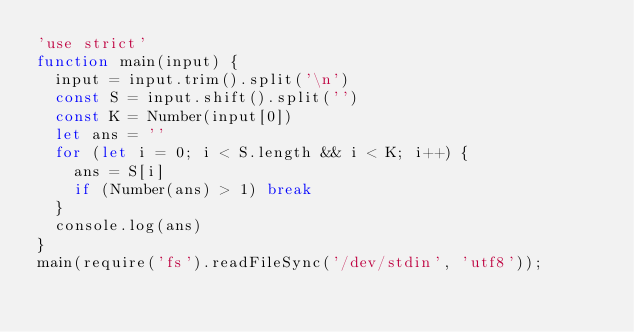<code> <loc_0><loc_0><loc_500><loc_500><_JavaScript_>'use strict'
function main(input) {
  input = input.trim().split('\n')
  const S = input.shift().split('')
  const K = Number(input[0])
  let ans = ''
  for (let i = 0; i < S.length && i < K; i++) {
    ans = S[i]
    if (Number(ans) > 1) break
  }
  console.log(ans)
}
main(require('fs').readFileSync('/dev/stdin', 'utf8'));
</code> 